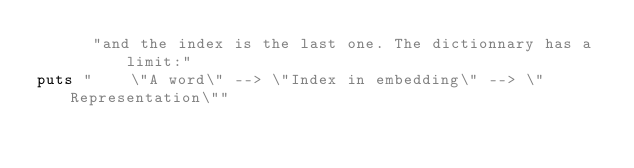Convert code to text. <code><loc_0><loc_0><loc_500><loc_500><_Ruby_>      "and the index is the last one. The dictionnary has a limit:"
puts "    \"A word\" --> \"Index in embedding\" --> \"Representation\""</code> 